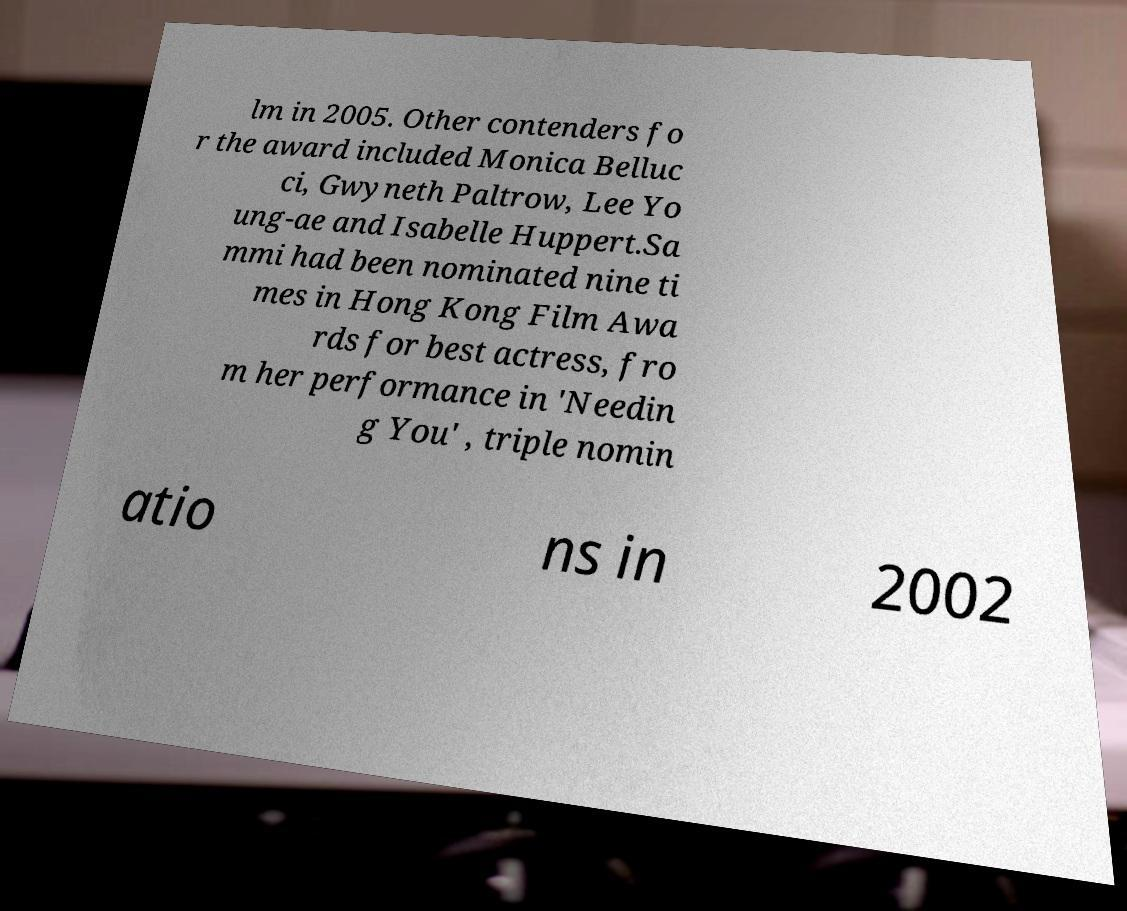Can you read and provide the text displayed in the image?This photo seems to have some interesting text. Can you extract and type it out for me? lm in 2005. Other contenders fo r the award included Monica Belluc ci, Gwyneth Paltrow, Lee Yo ung-ae and Isabelle Huppert.Sa mmi had been nominated nine ti mes in Hong Kong Film Awa rds for best actress, fro m her performance in 'Needin g You' , triple nomin atio ns in 2002 